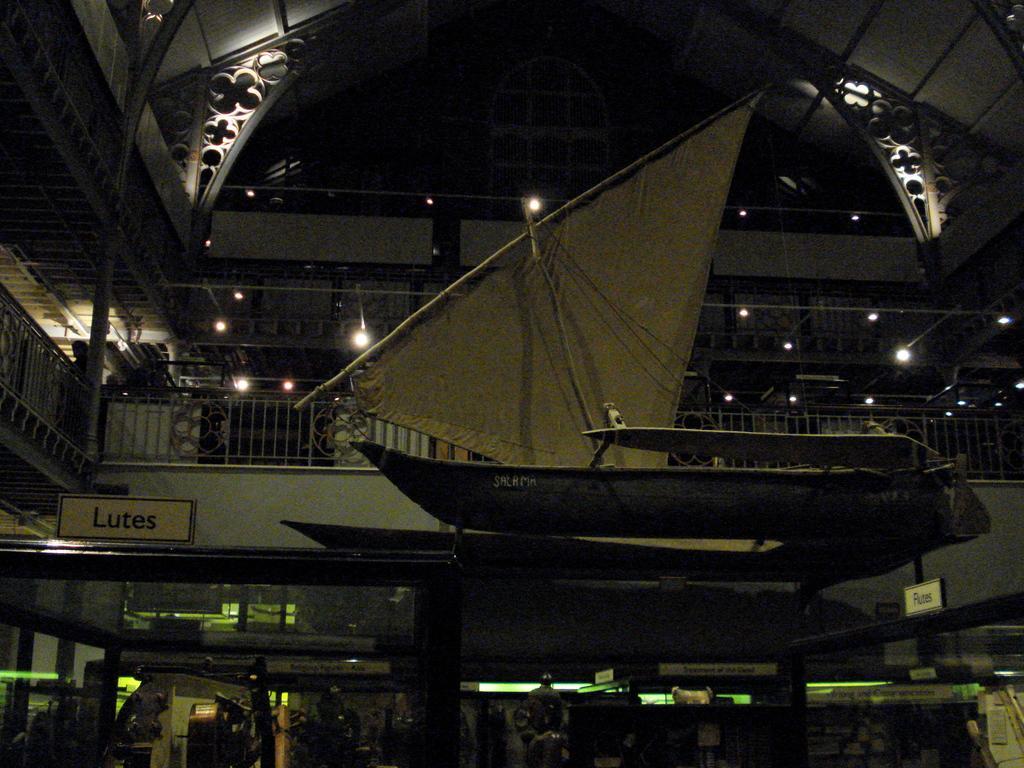Can you describe this image briefly? This is the inside picture of the building. In this image there is a structure of a boat. There is a metal fence. There are lights. There are name plates and there are shops. 